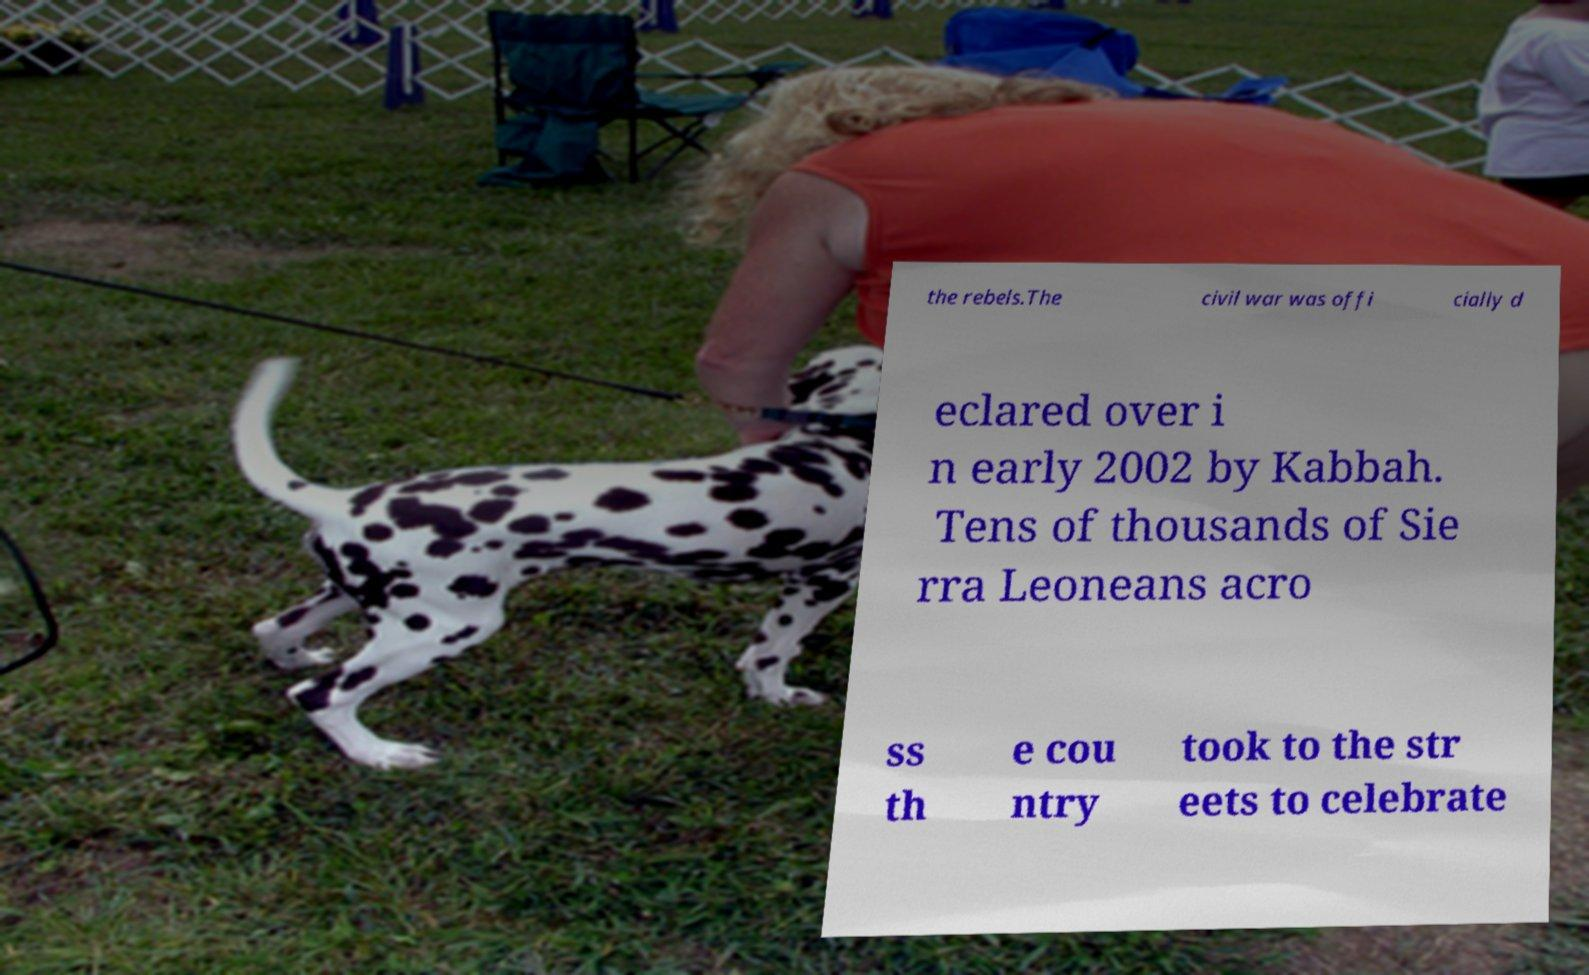Can you accurately transcribe the text from the provided image for me? the rebels.The civil war was offi cially d eclared over i n early 2002 by Kabbah. Tens of thousands of Sie rra Leoneans acro ss th e cou ntry took to the str eets to celebrate 